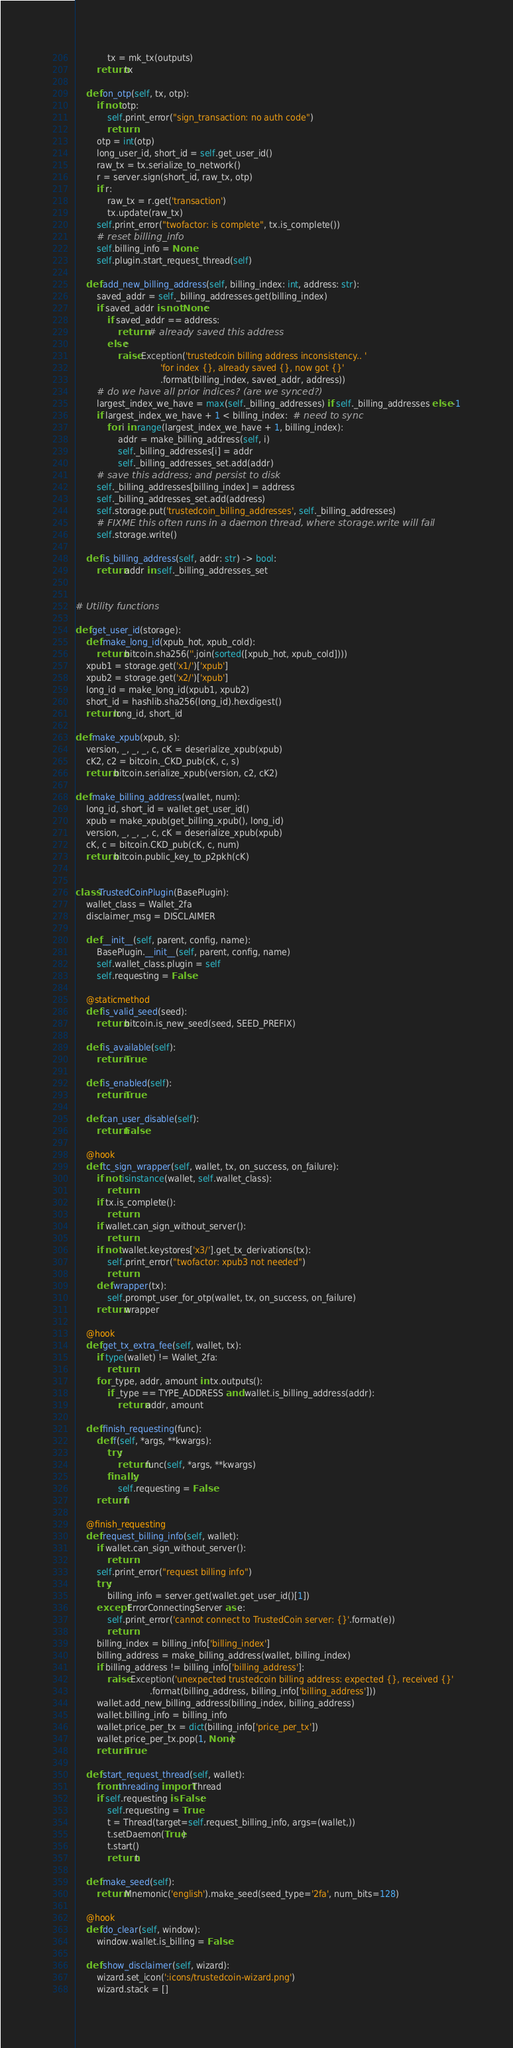Convert code to text. <code><loc_0><loc_0><loc_500><loc_500><_Python_>            tx = mk_tx(outputs)
        return tx

    def on_otp(self, tx, otp):
        if not otp:
            self.print_error("sign_transaction: no auth code")
            return
        otp = int(otp)
        long_user_id, short_id = self.get_user_id()
        raw_tx = tx.serialize_to_network()
        r = server.sign(short_id, raw_tx, otp)
        if r:
            raw_tx = r.get('transaction')
            tx.update(raw_tx)
        self.print_error("twofactor: is complete", tx.is_complete())
        # reset billing_info
        self.billing_info = None
        self.plugin.start_request_thread(self)

    def add_new_billing_address(self, billing_index: int, address: str):
        saved_addr = self._billing_addresses.get(billing_index)
        if saved_addr is not None:
            if saved_addr == address:
                return  # already saved this address
            else:
                raise Exception('trustedcoin billing address inconsistency.. '
                                'for index {}, already saved {}, now got {}'
                                .format(billing_index, saved_addr, address))
        # do we have all prior indices? (are we synced?)
        largest_index_we_have = max(self._billing_addresses) if self._billing_addresses else -1
        if largest_index_we_have + 1 < billing_index:  # need to sync
            for i in range(largest_index_we_have + 1, billing_index):
                addr = make_billing_address(self, i)
                self._billing_addresses[i] = addr
                self._billing_addresses_set.add(addr)
        # save this address; and persist to disk
        self._billing_addresses[billing_index] = address
        self._billing_addresses_set.add(address)
        self.storage.put('trustedcoin_billing_addresses', self._billing_addresses)
        # FIXME this often runs in a daemon thread, where storage.write will fail
        self.storage.write()

    def is_billing_address(self, addr: str) -> bool:
        return addr in self._billing_addresses_set


# Utility functions

def get_user_id(storage):
    def make_long_id(xpub_hot, xpub_cold):
        return bitcoin.sha256(''.join(sorted([xpub_hot, xpub_cold])))
    xpub1 = storage.get('x1/')['xpub']
    xpub2 = storage.get('x2/')['xpub']
    long_id = make_long_id(xpub1, xpub2)
    short_id = hashlib.sha256(long_id).hexdigest()
    return long_id, short_id

def make_xpub(xpub, s):
    version, _, _, _, c, cK = deserialize_xpub(xpub)
    cK2, c2 = bitcoin._CKD_pub(cK, c, s)
    return bitcoin.serialize_xpub(version, c2, cK2)

def make_billing_address(wallet, num):
    long_id, short_id = wallet.get_user_id()
    xpub = make_xpub(get_billing_xpub(), long_id)
    version, _, _, _, c, cK = deserialize_xpub(xpub)
    cK, c = bitcoin.CKD_pub(cK, c, num)
    return bitcoin.public_key_to_p2pkh(cK)


class TrustedCoinPlugin(BasePlugin):
    wallet_class = Wallet_2fa
    disclaimer_msg = DISCLAIMER

    def __init__(self, parent, config, name):
        BasePlugin.__init__(self, parent, config, name)
        self.wallet_class.plugin = self
        self.requesting = False

    @staticmethod
    def is_valid_seed(seed):
        return bitcoin.is_new_seed(seed, SEED_PREFIX)

    def is_available(self):
        return True

    def is_enabled(self):
        return True

    def can_user_disable(self):
        return False

    @hook
    def tc_sign_wrapper(self, wallet, tx, on_success, on_failure):
        if not isinstance(wallet, self.wallet_class):
            return
        if tx.is_complete():
            return
        if wallet.can_sign_without_server():
            return
        if not wallet.keystores['x3/'].get_tx_derivations(tx):
            self.print_error("twofactor: xpub3 not needed")
            return
        def wrapper(tx):
            self.prompt_user_for_otp(wallet, tx, on_success, on_failure)
        return wrapper

    @hook
    def get_tx_extra_fee(self, wallet, tx):
        if type(wallet) != Wallet_2fa:
            return
        for _type, addr, amount in tx.outputs():
            if _type == TYPE_ADDRESS and wallet.is_billing_address(addr):
                return addr, amount

    def finish_requesting(func):
        def f(self, *args, **kwargs):
            try:
                return func(self, *args, **kwargs)
            finally:
                self.requesting = False
        return f

    @finish_requesting
    def request_billing_info(self, wallet):
        if wallet.can_sign_without_server():
            return
        self.print_error("request billing info")
        try:
            billing_info = server.get(wallet.get_user_id()[1])
        except ErrorConnectingServer as e:
            self.print_error('cannot connect to TrustedCoin server: {}'.format(e))
            return
        billing_index = billing_info['billing_index']
        billing_address = make_billing_address(wallet, billing_index)
        if billing_address != billing_info['billing_address']:
            raise Exception('unexpected trustedcoin billing address: expected {}, received {}'
                            .format(billing_address, billing_info['billing_address']))
        wallet.add_new_billing_address(billing_index, billing_address)
        wallet.billing_info = billing_info
        wallet.price_per_tx = dict(billing_info['price_per_tx'])
        wallet.price_per_tx.pop(1, None)
        return True

    def start_request_thread(self, wallet):
        from threading import Thread
        if self.requesting is False:
            self.requesting = True
            t = Thread(target=self.request_billing_info, args=(wallet,))
            t.setDaemon(True)
            t.start()
            return t

    def make_seed(self):
        return Mnemonic('english').make_seed(seed_type='2fa', num_bits=128)

    @hook
    def do_clear(self, window):
        window.wallet.is_billing = False

    def show_disclaimer(self, wizard):
        wizard.set_icon(':icons/trustedcoin-wizard.png')
        wizard.stack = []</code> 